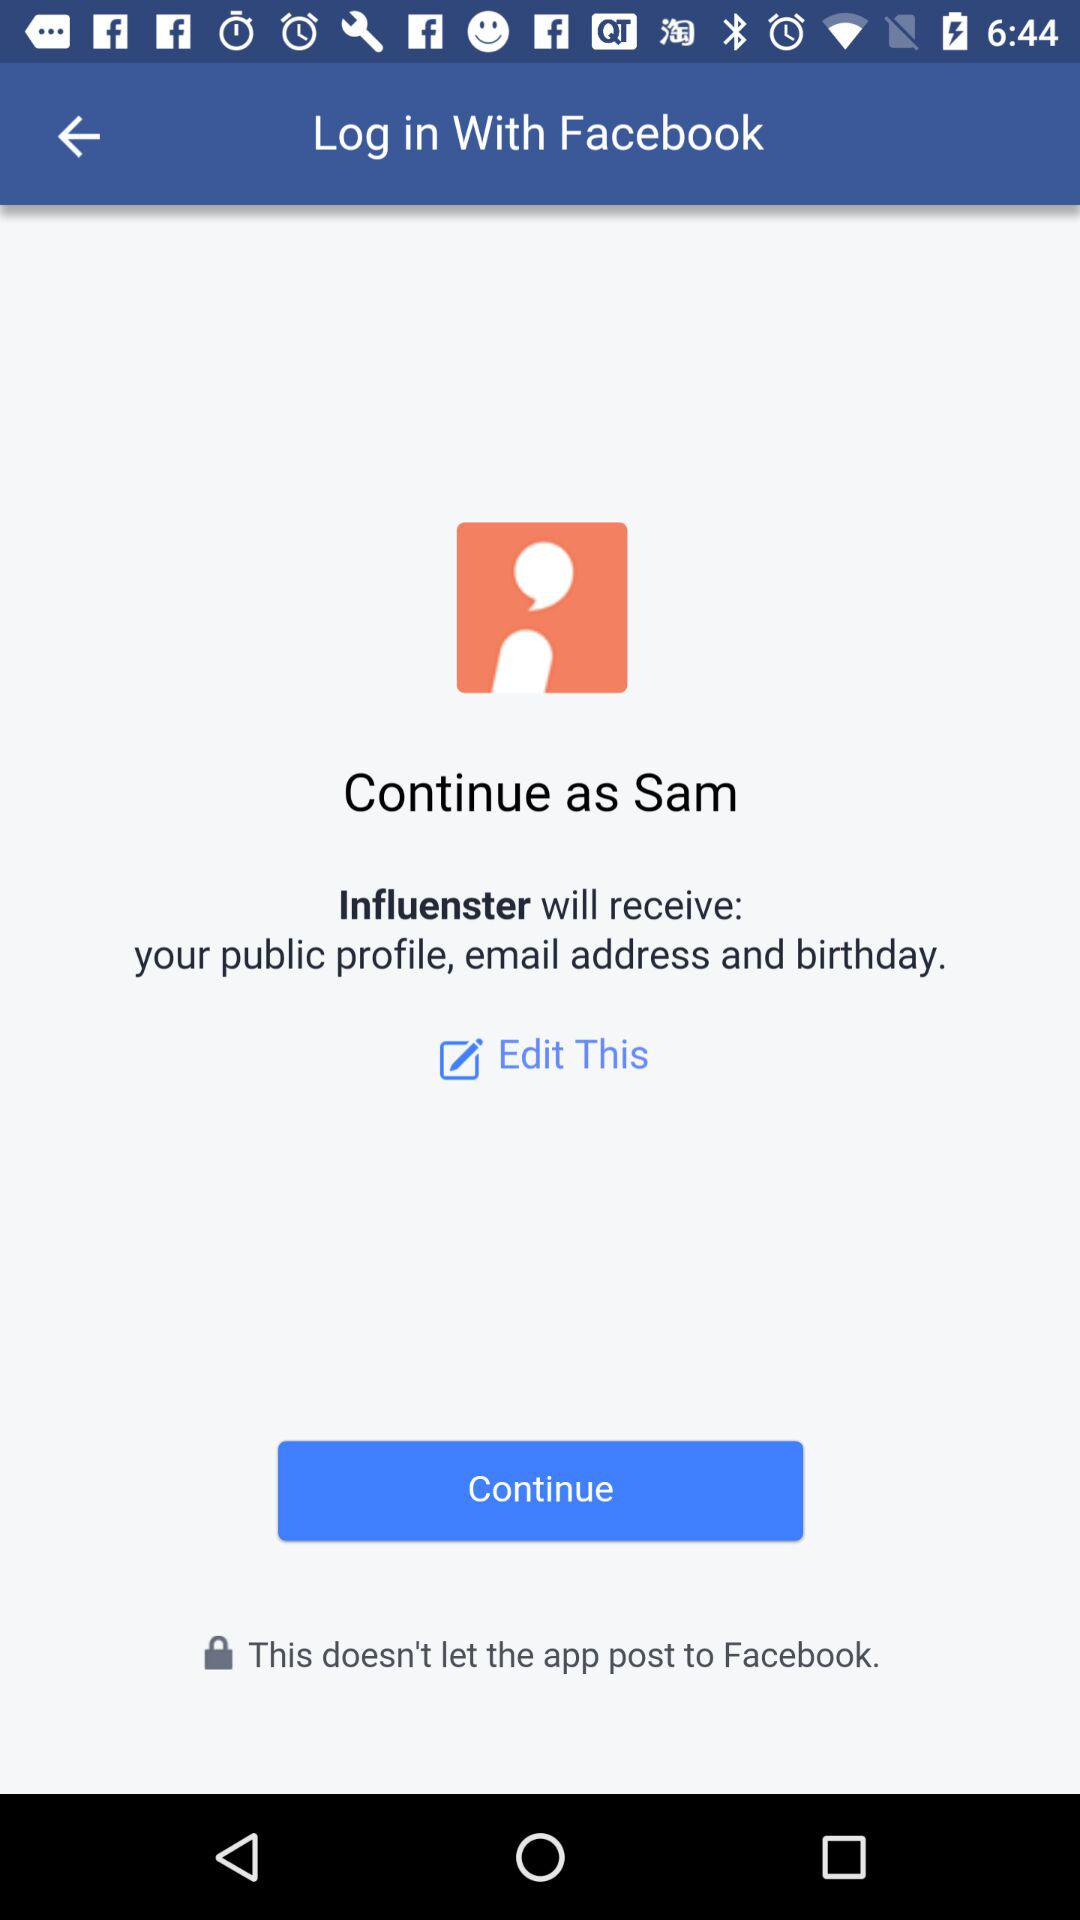What is the name of the user? The name of the user is Sam. 